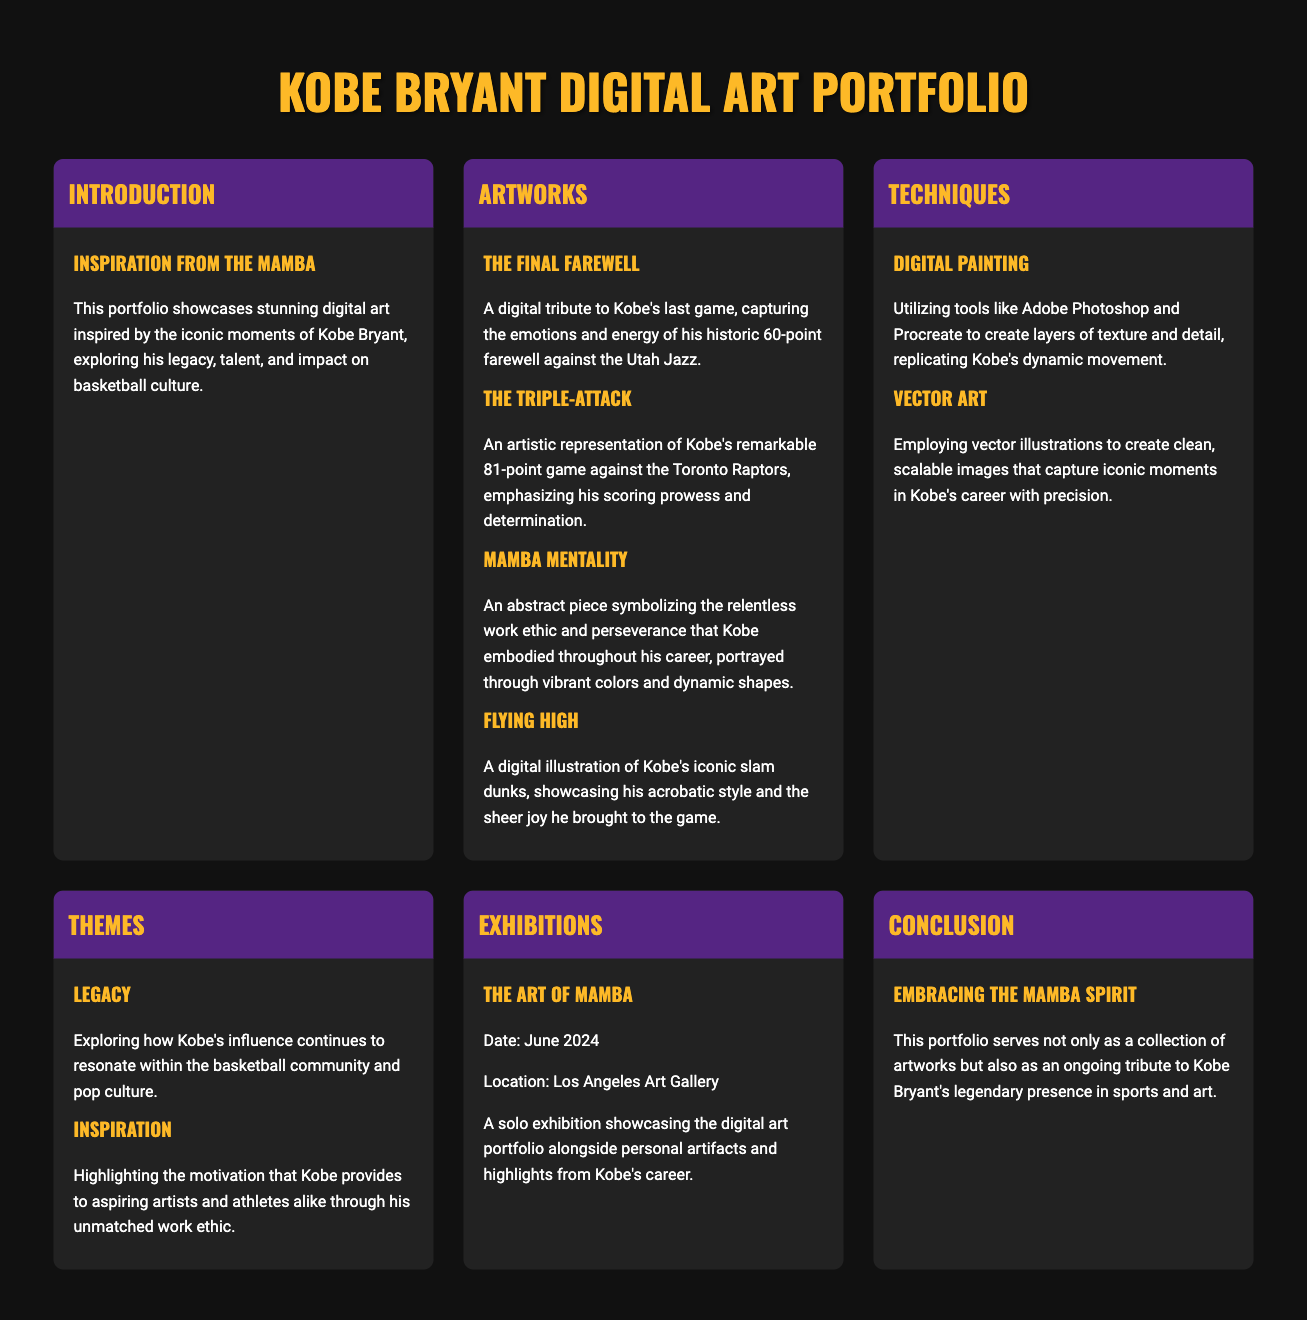What is the title of the portfolio? The title of the portfolio is prominently displayed as "Kobe Bryant Digital Art Portfolio."
Answer: Kobe Bryant Digital Art Portfolio When is "The Art of Mamba" exhibition taking place? The date of the exhibition is mentioned as June 2024.
Answer: June 2024 What is the name of the artwork that captures Kobe's last game? The artwork is titled "The Final Farewell."
Answer: The Final Farewell What artistic technique is used to replicate dynamic movements? The technique mentioned is "Digital Painting."
Answer: Digital Painting Which theme highlights Kobe's influence on aspiring artists? The theme that highlights this is "Inspiration."
Answer: Inspiration How many artworks are listed in the "Artworks" section? The number of artworks listed is four: The Final Farewell, The Triple-Attack, Mamba Mentality, and Flying High.
Answer: Four What color is used for the background of the portfolio? The background color of the portfolio design is specified as #111, a very dark shade.
Answer: #111 What is the main focus of the "Introduction" section? The main focus is on showcasing digital art inspired by Kobe's iconic moments, highlighting his legacy and impact.
Answer: Legacy and impact What is the location of "The Art of Mamba" exhibition? The location mentioned for the exhibition is the Los Angeles Art Gallery.
Answer: Los Angeles Art Gallery 